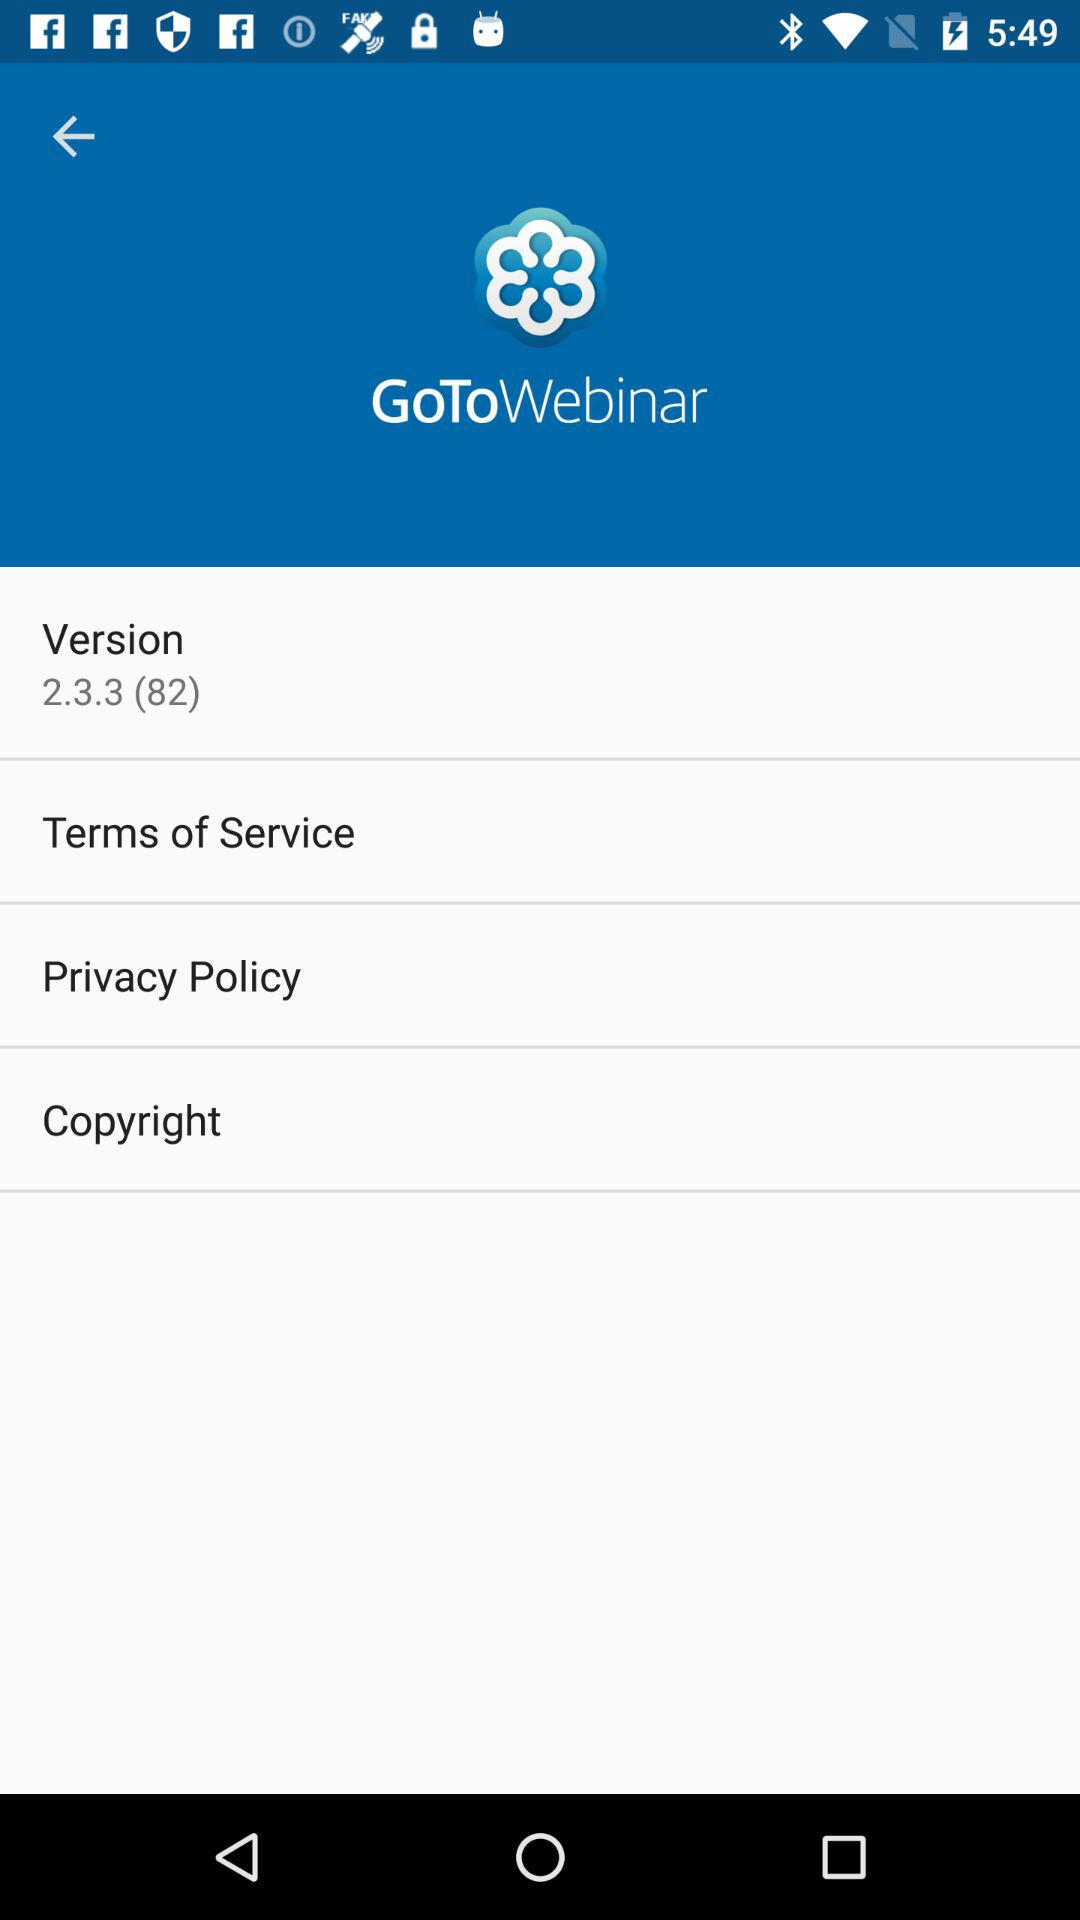What is the name of the application? The name of the application is "GoToWebinar". 